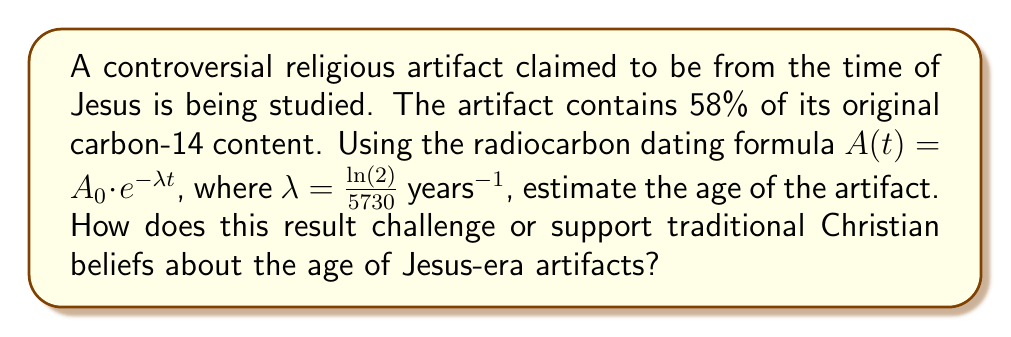Can you solve this math problem? To solve this problem, we'll use the radiocarbon dating formula and the given information:

1) The formula is $A(t) = A_0 \cdot e^{-\lambda t}$, where:
   $A(t)$ is the amount of carbon-14 remaining after time $t$
   $A_0$ is the initial amount of carbon-14
   $\lambda = \frac{\ln(2)}{5730}$ years$^{-1}$ (given)
   $t$ is the time elapsed (what we're solving for)

2) We know that 58% of the original carbon-14 remains, so:
   $\frac{A(t)}{A_0} = 0.58$

3) Substituting this into the formula:
   $0.58 = e^{-\lambda t}$

4) Taking the natural log of both sides:
   $\ln(0.58) = -\lambda t$

5) Solving for $t$:
   $t = -\frac{\ln(0.58)}{\lambda} = -\frac{\ln(0.58)}{\frac{\ln(2)}{5730}}$

6) Simplifying:
   $t = 5730 \cdot \frac{-\ln(0.58)}{\ln(2)} \approx 4525.8$ years

This result suggests the artifact is approximately 4,526 years old, dating it to around 2500 BCE. This is significantly older than the time of Jesus (approximately 2000 years ago), challenging traditional Christian beliefs about artifacts from Jesus' era. It raises questions about the authenticity of the artifact or the accuracy of its claimed association with Jesus' time.
Answer: 4,526 years 